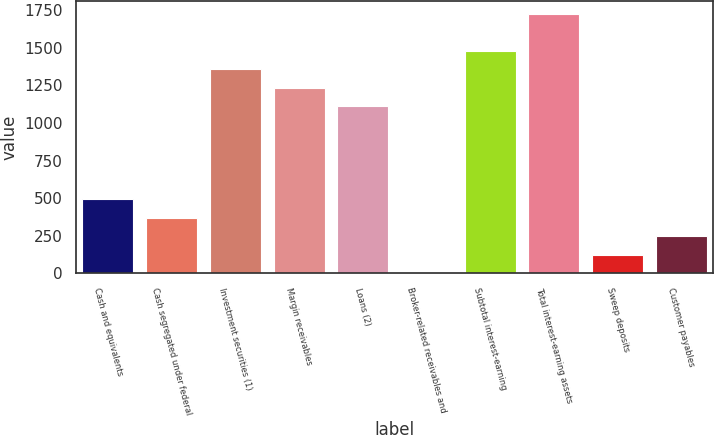<chart> <loc_0><loc_0><loc_500><loc_500><bar_chart><fcel>Cash and equivalents<fcel>Cash segregated under federal<fcel>Investment securities (1)<fcel>Margin receivables<fcel>Loans (2)<fcel>Broker-related receivables and<fcel>Subtotal interest-earning<fcel>Total interest-earning assets<fcel>Sweep deposits<fcel>Customer payables<nl><fcel>493.8<fcel>370.6<fcel>1356.2<fcel>1233<fcel>1109.8<fcel>1<fcel>1479.4<fcel>1725.8<fcel>124.2<fcel>247.4<nl></chart> 